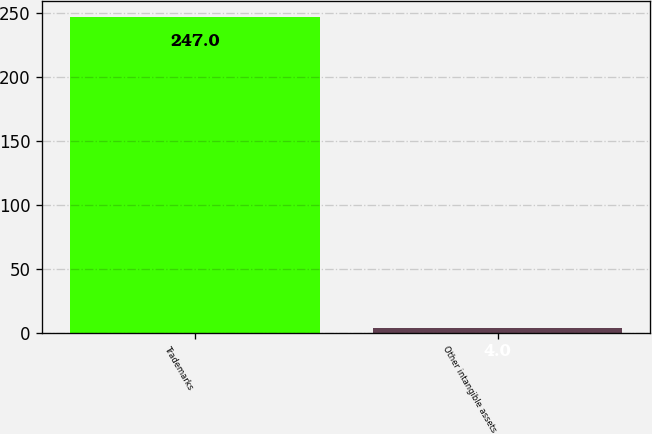<chart> <loc_0><loc_0><loc_500><loc_500><bar_chart><fcel>Trademarks<fcel>Other intangible assets<nl><fcel>247<fcel>4<nl></chart> 